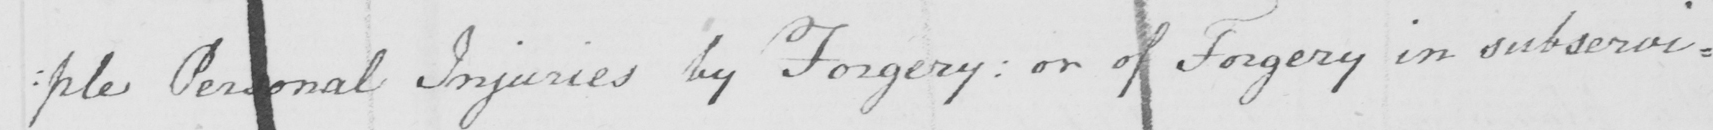What is written in this line of handwriting? : ple Personal Injuries by Forgery :  or of Forgery in subservi= 